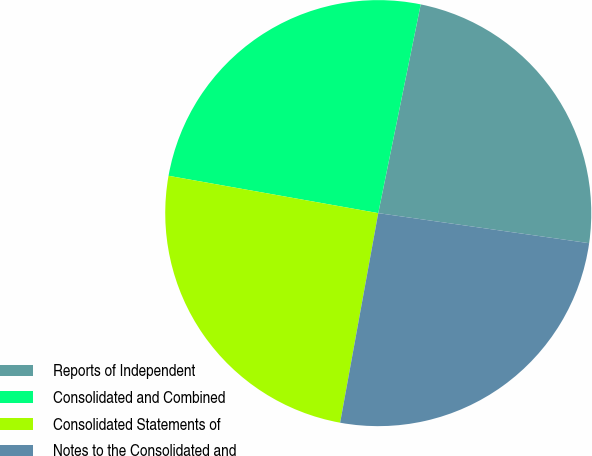Convert chart. <chart><loc_0><loc_0><loc_500><loc_500><pie_chart><fcel>Reports of Independent<fcel>Consolidated and Combined<fcel>Consolidated Statements of<fcel>Notes to the Consolidated and<nl><fcel>24.06%<fcel>25.39%<fcel>24.94%<fcel>25.61%<nl></chart> 